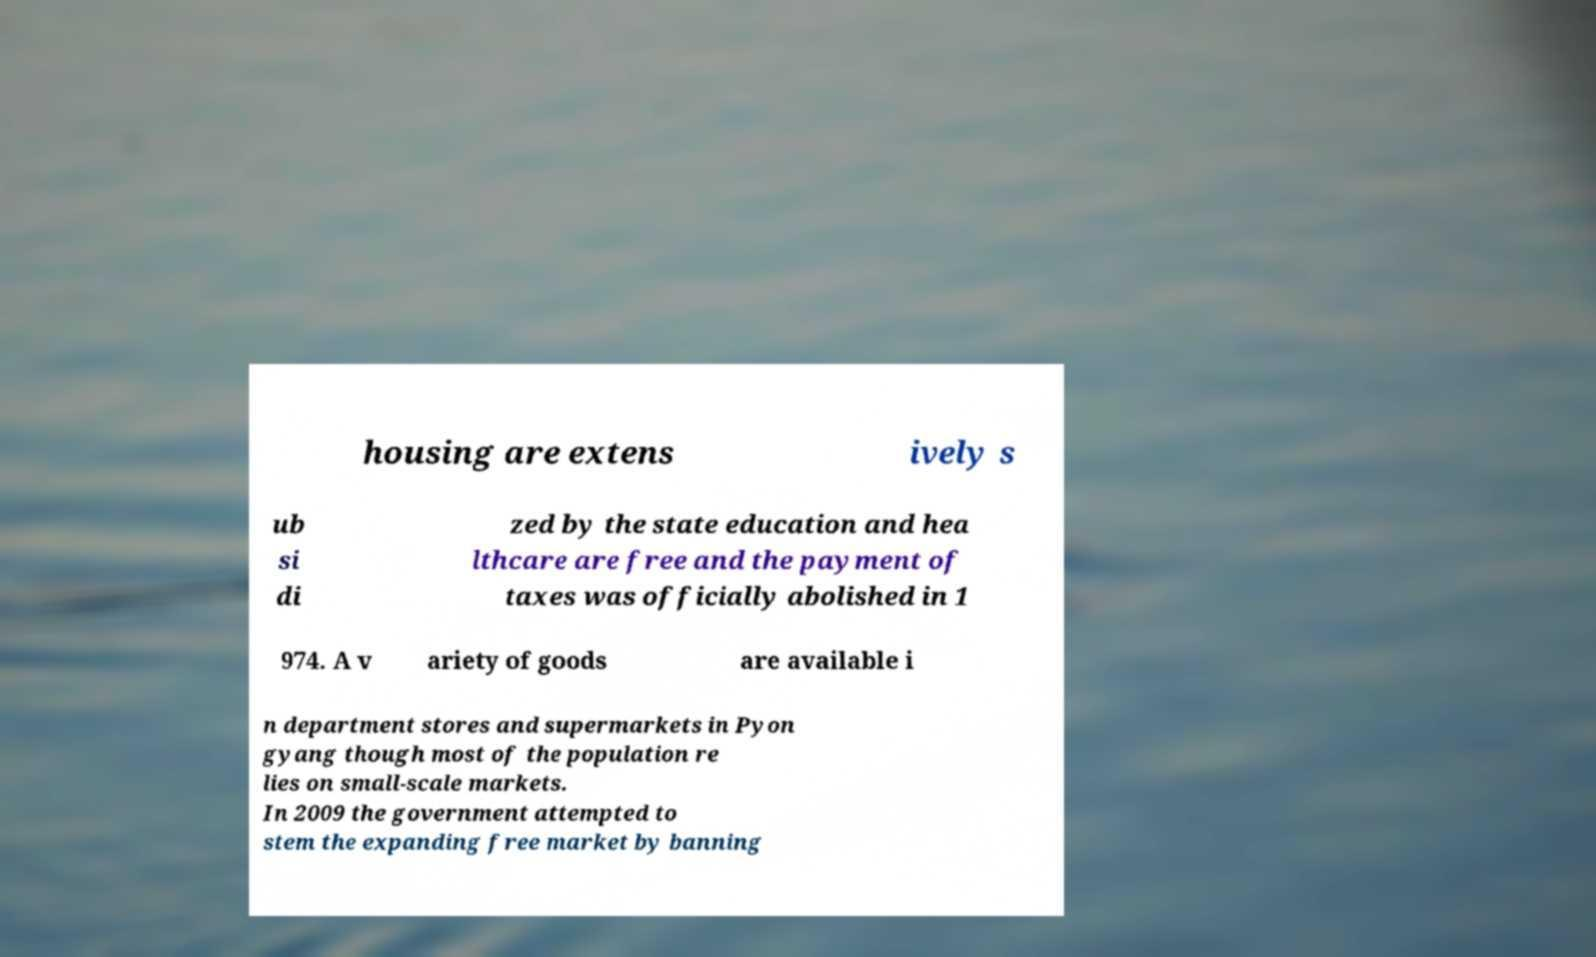Could you assist in decoding the text presented in this image and type it out clearly? housing are extens ively s ub si di zed by the state education and hea lthcare are free and the payment of taxes was officially abolished in 1 974. A v ariety of goods are available i n department stores and supermarkets in Pyon gyang though most of the population re lies on small-scale markets. In 2009 the government attempted to stem the expanding free market by banning 